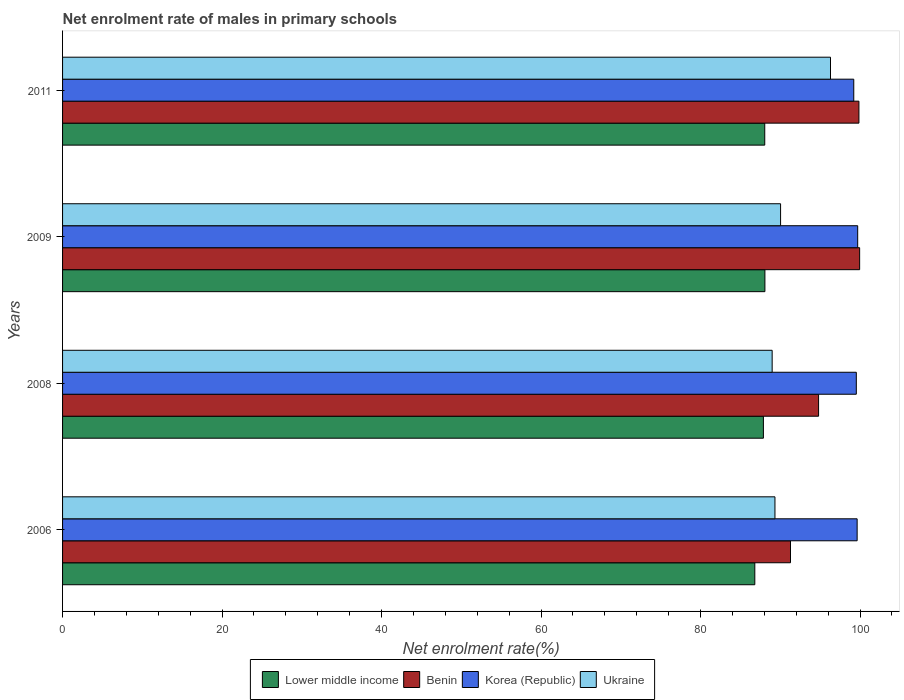How many groups of bars are there?
Offer a terse response. 4. Are the number of bars per tick equal to the number of legend labels?
Offer a very short reply. Yes. Are the number of bars on each tick of the Y-axis equal?
Your answer should be very brief. Yes. What is the label of the 2nd group of bars from the top?
Your answer should be compact. 2009. What is the net enrolment rate of males in primary schools in Benin in 2006?
Give a very brief answer. 91.28. Across all years, what is the maximum net enrolment rate of males in primary schools in Lower middle income?
Ensure brevity in your answer.  88.07. Across all years, what is the minimum net enrolment rate of males in primary schools in Lower middle income?
Provide a succinct answer. 86.81. In which year was the net enrolment rate of males in primary schools in Benin maximum?
Provide a succinct answer. 2009. What is the total net enrolment rate of males in primary schools in Korea (Republic) in the graph?
Keep it short and to the point. 398.1. What is the difference between the net enrolment rate of males in primary schools in Benin in 2006 and that in 2008?
Your answer should be compact. -3.52. What is the difference between the net enrolment rate of males in primary schools in Korea (Republic) in 2006 and the net enrolment rate of males in primary schools in Ukraine in 2009?
Ensure brevity in your answer.  9.6. What is the average net enrolment rate of males in primary schools in Ukraine per year?
Your response must be concise. 91.16. In the year 2009, what is the difference between the net enrolment rate of males in primary schools in Korea (Republic) and net enrolment rate of males in primary schools in Benin?
Keep it short and to the point. -0.24. In how many years, is the net enrolment rate of males in primary schools in Korea (Republic) greater than 100 %?
Your response must be concise. 0. What is the ratio of the net enrolment rate of males in primary schools in Lower middle income in 2009 to that in 2011?
Your answer should be very brief. 1. Is the net enrolment rate of males in primary schools in Ukraine in 2009 less than that in 2011?
Provide a succinct answer. Yes. Is the difference between the net enrolment rate of males in primary schools in Korea (Republic) in 2006 and 2008 greater than the difference between the net enrolment rate of males in primary schools in Benin in 2006 and 2008?
Your answer should be very brief. Yes. What is the difference between the highest and the second highest net enrolment rate of males in primary schools in Ukraine?
Your answer should be compact. 6.26. What is the difference between the highest and the lowest net enrolment rate of males in primary schools in Korea (Republic)?
Give a very brief answer. 0.49. Is the sum of the net enrolment rate of males in primary schools in Lower middle income in 2008 and 2011 greater than the maximum net enrolment rate of males in primary schools in Benin across all years?
Keep it short and to the point. Yes. Is it the case that in every year, the sum of the net enrolment rate of males in primary schools in Lower middle income and net enrolment rate of males in primary schools in Ukraine is greater than the sum of net enrolment rate of males in primary schools in Benin and net enrolment rate of males in primary schools in Korea (Republic)?
Offer a very short reply. No. What does the 2nd bar from the top in 2008 represents?
Your answer should be very brief. Korea (Republic). What does the 2nd bar from the bottom in 2011 represents?
Make the answer very short. Benin. How many years are there in the graph?
Your answer should be very brief. 4. What is the difference between two consecutive major ticks on the X-axis?
Your answer should be very brief. 20. Are the values on the major ticks of X-axis written in scientific E-notation?
Your response must be concise. No. How are the legend labels stacked?
Provide a short and direct response. Horizontal. What is the title of the graph?
Your answer should be compact. Net enrolment rate of males in primary schools. What is the label or title of the X-axis?
Make the answer very short. Net enrolment rate(%). What is the label or title of the Y-axis?
Offer a very short reply. Years. What is the Net enrolment rate(%) of Lower middle income in 2006?
Provide a succinct answer. 86.81. What is the Net enrolment rate(%) of Benin in 2006?
Ensure brevity in your answer.  91.28. What is the Net enrolment rate(%) of Korea (Republic) in 2006?
Your answer should be very brief. 99.64. What is the Net enrolment rate(%) of Ukraine in 2006?
Provide a succinct answer. 89.33. What is the Net enrolment rate(%) of Lower middle income in 2008?
Your answer should be very brief. 87.88. What is the Net enrolment rate(%) of Benin in 2008?
Give a very brief answer. 94.8. What is the Net enrolment rate(%) in Korea (Republic) in 2008?
Your answer should be very brief. 99.54. What is the Net enrolment rate(%) in Ukraine in 2008?
Provide a short and direct response. 88.98. What is the Net enrolment rate(%) in Lower middle income in 2009?
Make the answer very short. 88.07. What is the Net enrolment rate(%) in Benin in 2009?
Your response must be concise. 99.95. What is the Net enrolment rate(%) in Korea (Republic) in 2009?
Give a very brief answer. 99.71. What is the Net enrolment rate(%) in Ukraine in 2009?
Your response must be concise. 90.04. What is the Net enrolment rate(%) in Lower middle income in 2011?
Make the answer very short. 88.05. What is the Net enrolment rate(%) in Benin in 2011?
Offer a terse response. 99.86. What is the Net enrolment rate(%) of Korea (Republic) in 2011?
Keep it short and to the point. 99.22. What is the Net enrolment rate(%) of Ukraine in 2011?
Offer a very short reply. 96.3. Across all years, what is the maximum Net enrolment rate(%) of Lower middle income?
Keep it short and to the point. 88.07. Across all years, what is the maximum Net enrolment rate(%) in Benin?
Ensure brevity in your answer.  99.95. Across all years, what is the maximum Net enrolment rate(%) of Korea (Republic)?
Give a very brief answer. 99.71. Across all years, what is the maximum Net enrolment rate(%) of Ukraine?
Your answer should be compact. 96.3. Across all years, what is the minimum Net enrolment rate(%) of Lower middle income?
Keep it short and to the point. 86.81. Across all years, what is the minimum Net enrolment rate(%) in Benin?
Your answer should be compact. 91.28. Across all years, what is the minimum Net enrolment rate(%) in Korea (Republic)?
Your answer should be very brief. 99.22. Across all years, what is the minimum Net enrolment rate(%) of Ukraine?
Make the answer very short. 88.98. What is the total Net enrolment rate(%) in Lower middle income in the graph?
Your answer should be compact. 350.82. What is the total Net enrolment rate(%) of Benin in the graph?
Your answer should be very brief. 385.9. What is the total Net enrolment rate(%) of Korea (Republic) in the graph?
Offer a terse response. 398.1. What is the total Net enrolment rate(%) of Ukraine in the graph?
Your answer should be very brief. 364.65. What is the difference between the Net enrolment rate(%) in Lower middle income in 2006 and that in 2008?
Offer a very short reply. -1.08. What is the difference between the Net enrolment rate(%) in Benin in 2006 and that in 2008?
Your answer should be very brief. -3.52. What is the difference between the Net enrolment rate(%) in Korea (Republic) in 2006 and that in 2008?
Provide a short and direct response. 0.1. What is the difference between the Net enrolment rate(%) in Ukraine in 2006 and that in 2008?
Offer a very short reply. 0.35. What is the difference between the Net enrolment rate(%) in Lower middle income in 2006 and that in 2009?
Keep it short and to the point. -1.27. What is the difference between the Net enrolment rate(%) of Benin in 2006 and that in 2009?
Give a very brief answer. -8.67. What is the difference between the Net enrolment rate(%) of Korea (Republic) in 2006 and that in 2009?
Give a very brief answer. -0.07. What is the difference between the Net enrolment rate(%) in Ukraine in 2006 and that in 2009?
Your response must be concise. -0.71. What is the difference between the Net enrolment rate(%) of Lower middle income in 2006 and that in 2011?
Ensure brevity in your answer.  -1.25. What is the difference between the Net enrolment rate(%) in Benin in 2006 and that in 2011?
Offer a very short reply. -8.58. What is the difference between the Net enrolment rate(%) of Korea (Republic) in 2006 and that in 2011?
Give a very brief answer. 0.42. What is the difference between the Net enrolment rate(%) of Ukraine in 2006 and that in 2011?
Your response must be concise. -6.97. What is the difference between the Net enrolment rate(%) of Lower middle income in 2008 and that in 2009?
Make the answer very short. -0.19. What is the difference between the Net enrolment rate(%) in Benin in 2008 and that in 2009?
Provide a succinct answer. -5.15. What is the difference between the Net enrolment rate(%) of Korea (Republic) in 2008 and that in 2009?
Keep it short and to the point. -0.17. What is the difference between the Net enrolment rate(%) in Ukraine in 2008 and that in 2009?
Provide a short and direct response. -1.06. What is the difference between the Net enrolment rate(%) in Lower middle income in 2008 and that in 2011?
Your answer should be very brief. -0.17. What is the difference between the Net enrolment rate(%) in Benin in 2008 and that in 2011?
Your response must be concise. -5.06. What is the difference between the Net enrolment rate(%) of Korea (Republic) in 2008 and that in 2011?
Ensure brevity in your answer.  0.32. What is the difference between the Net enrolment rate(%) in Ukraine in 2008 and that in 2011?
Keep it short and to the point. -7.32. What is the difference between the Net enrolment rate(%) of Lower middle income in 2009 and that in 2011?
Offer a very short reply. 0.02. What is the difference between the Net enrolment rate(%) of Benin in 2009 and that in 2011?
Ensure brevity in your answer.  0.09. What is the difference between the Net enrolment rate(%) of Korea (Republic) in 2009 and that in 2011?
Your response must be concise. 0.49. What is the difference between the Net enrolment rate(%) in Ukraine in 2009 and that in 2011?
Make the answer very short. -6.26. What is the difference between the Net enrolment rate(%) in Lower middle income in 2006 and the Net enrolment rate(%) in Benin in 2008?
Make the answer very short. -8. What is the difference between the Net enrolment rate(%) in Lower middle income in 2006 and the Net enrolment rate(%) in Korea (Republic) in 2008?
Offer a terse response. -12.73. What is the difference between the Net enrolment rate(%) in Lower middle income in 2006 and the Net enrolment rate(%) in Ukraine in 2008?
Provide a succinct answer. -2.18. What is the difference between the Net enrolment rate(%) of Benin in 2006 and the Net enrolment rate(%) of Korea (Republic) in 2008?
Offer a very short reply. -8.25. What is the difference between the Net enrolment rate(%) of Benin in 2006 and the Net enrolment rate(%) of Ukraine in 2008?
Offer a terse response. 2.3. What is the difference between the Net enrolment rate(%) of Korea (Republic) in 2006 and the Net enrolment rate(%) of Ukraine in 2008?
Your answer should be compact. 10.66. What is the difference between the Net enrolment rate(%) in Lower middle income in 2006 and the Net enrolment rate(%) in Benin in 2009?
Provide a succinct answer. -13.15. What is the difference between the Net enrolment rate(%) in Lower middle income in 2006 and the Net enrolment rate(%) in Korea (Republic) in 2009?
Ensure brevity in your answer.  -12.9. What is the difference between the Net enrolment rate(%) of Lower middle income in 2006 and the Net enrolment rate(%) of Ukraine in 2009?
Your answer should be very brief. -3.23. What is the difference between the Net enrolment rate(%) in Benin in 2006 and the Net enrolment rate(%) in Korea (Republic) in 2009?
Your answer should be compact. -8.43. What is the difference between the Net enrolment rate(%) in Benin in 2006 and the Net enrolment rate(%) in Ukraine in 2009?
Offer a terse response. 1.24. What is the difference between the Net enrolment rate(%) of Korea (Republic) in 2006 and the Net enrolment rate(%) of Ukraine in 2009?
Your answer should be compact. 9.6. What is the difference between the Net enrolment rate(%) in Lower middle income in 2006 and the Net enrolment rate(%) in Benin in 2011?
Ensure brevity in your answer.  -13.06. What is the difference between the Net enrolment rate(%) in Lower middle income in 2006 and the Net enrolment rate(%) in Korea (Republic) in 2011?
Offer a terse response. -12.41. What is the difference between the Net enrolment rate(%) of Lower middle income in 2006 and the Net enrolment rate(%) of Ukraine in 2011?
Your answer should be compact. -9.49. What is the difference between the Net enrolment rate(%) in Benin in 2006 and the Net enrolment rate(%) in Korea (Republic) in 2011?
Ensure brevity in your answer.  -7.94. What is the difference between the Net enrolment rate(%) of Benin in 2006 and the Net enrolment rate(%) of Ukraine in 2011?
Ensure brevity in your answer.  -5.02. What is the difference between the Net enrolment rate(%) in Korea (Republic) in 2006 and the Net enrolment rate(%) in Ukraine in 2011?
Offer a terse response. 3.34. What is the difference between the Net enrolment rate(%) of Lower middle income in 2008 and the Net enrolment rate(%) of Benin in 2009?
Your answer should be compact. -12.07. What is the difference between the Net enrolment rate(%) of Lower middle income in 2008 and the Net enrolment rate(%) of Korea (Republic) in 2009?
Offer a terse response. -11.82. What is the difference between the Net enrolment rate(%) of Lower middle income in 2008 and the Net enrolment rate(%) of Ukraine in 2009?
Offer a very short reply. -2.15. What is the difference between the Net enrolment rate(%) in Benin in 2008 and the Net enrolment rate(%) in Korea (Republic) in 2009?
Provide a short and direct response. -4.9. What is the difference between the Net enrolment rate(%) in Benin in 2008 and the Net enrolment rate(%) in Ukraine in 2009?
Offer a very short reply. 4.77. What is the difference between the Net enrolment rate(%) in Korea (Republic) in 2008 and the Net enrolment rate(%) in Ukraine in 2009?
Make the answer very short. 9.5. What is the difference between the Net enrolment rate(%) in Lower middle income in 2008 and the Net enrolment rate(%) in Benin in 2011?
Make the answer very short. -11.98. What is the difference between the Net enrolment rate(%) in Lower middle income in 2008 and the Net enrolment rate(%) in Korea (Republic) in 2011?
Make the answer very short. -11.33. What is the difference between the Net enrolment rate(%) of Lower middle income in 2008 and the Net enrolment rate(%) of Ukraine in 2011?
Make the answer very short. -8.41. What is the difference between the Net enrolment rate(%) in Benin in 2008 and the Net enrolment rate(%) in Korea (Republic) in 2011?
Give a very brief answer. -4.41. What is the difference between the Net enrolment rate(%) of Benin in 2008 and the Net enrolment rate(%) of Ukraine in 2011?
Keep it short and to the point. -1.49. What is the difference between the Net enrolment rate(%) in Korea (Republic) in 2008 and the Net enrolment rate(%) in Ukraine in 2011?
Ensure brevity in your answer.  3.24. What is the difference between the Net enrolment rate(%) in Lower middle income in 2009 and the Net enrolment rate(%) in Benin in 2011?
Ensure brevity in your answer.  -11.79. What is the difference between the Net enrolment rate(%) in Lower middle income in 2009 and the Net enrolment rate(%) in Korea (Republic) in 2011?
Your response must be concise. -11.14. What is the difference between the Net enrolment rate(%) of Lower middle income in 2009 and the Net enrolment rate(%) of Ukraine in 2011?
Provide a short and direct response. -8.23. What is the difference between the Net enrolment rate(%) in Benin in 2009 and the Net enrolment rate(%) in Korea (Republic) in 2011?
Provide a short and direct response. 0.74. What is the difference between the Net enrolment rate(%) of Benin in 2009 and the Net enrolment rate(%) of Ukraine in 2011?
Provide a short and direct response. 3.65. What is the difference between the Net enrolment rate(%) of Korea (Republic) in 2009 and the Net enrolment rate(%) of Ukraine in 2011?
Offer a terse response. 3.41. What is the average Net enrolment rate(%) in Lower middle income per year?
Keep it short and to the point. 87.7. What is the average Net enrolment rate(%) of Benin per year?
Provide a succinct answer. 96.48. What is the average Net enrolment rate(%) in Korea (Republic) per year?
Your response must be concise. 99.52. What is the average Net enrolment rate(%) in Ukraine per year?
Provide a short and direct response. 91.16. In the year 2006, what is the difference between the Net enrolment rate(%) in Lower middle income and Net enrolment rate(%) in Benin?
Provide a short and direct response. -4.47. In the year 2006, what is the difference between the Net enrolment rate(%) of Lower middle income and Net enrolment rate(%) of Korea (Republic)?
Ensure brevity in your answer.  -12.83. In the year 2006, what is the difference between the Net enrolment rate(%) in Lower middle income and Net enrolment rate(%) in Ukraine?
Provide a short and direct response. -2.53. In the year 2006, what is the difference between the Net enrolment rate(%) of Benin and Net enrolment rate(%) of Korea (Republic)?
Your response must be concise. -8.36. In the year 2006, what is the difference between the Net enrolment rate(%) in Benin and Net enrolment rate(%) in Ukraine?
Provide a succinct answer. 1.95. In the year 2006, what is the difference between the Net enrolment rate(%) of Korea (Republic) and Net enrolment rate(%) of Ukraine?
Provide a succinct answer. 10.31. In the year 2008, what is the difference between the Net enrolment rate(%) of Lower middle income and Net enrolment rate(%) of Benin?
Make the answer very short. -6.92. In the year 2008, what is the difference between the Net enrolment rate(%) of Lower middle income and Net enrolment rate(%) of Korea (Republic)?
Make the answer very short. -11.65. In the year 2008, what is the difference between the Net enrolment rate(%) in Lower middle income and Net enrolment rate(%) in Ukraine?
Your response must be concise. -1.1. In the year 2008, what is the difference between the Net enrolment rate(%) of Benin and Net enrolment rate(%) of Korea (Republic)?
Make the answer very short. -4.73. In the year 2008, what is the difference between the Net enrolment rate(%) in Benin and Net enrolment rate(%) in Ukraine?
Your answer should be compact. 5.82. In the year 2008, what is the difference between the Net enrolment rate(%) in Korea (Republic) and Net enrolment rate(%) in Ukraine?
Your answer should be compact. 10.55. In the year 2009, what is the difference between the Net enrolment rate(%) of Lower middle income and Net enrolment rate(%) of Benin?
Give a very brief answer. -11.88. In the year 2009, what is the difference between the Net enrolment rate(%) of Lower middle income and Net enrolment rate(%) of Korea (Republic)?
Ensure brevity in your answer.  -11.63. In the year 2009, what is the difference between the Net enrolment rate(%) of Lower middle income and Net enrolment rate(%) of Ukraine?
Your answer should be very brief. -1.97. In the year 2009, what is the difference between the Net enrolment rate(%) of Benin and Net enrolment rate(%) of Korea (Republic)?
Provide a short and direct response. 0.24. In the year 2009, what is the difference between the Net enrolment rate(%) of Benin and Net enrolment rate(%) of Ukraine?
Give a very brief answer. 9.91. In the year 2009, what is the difference between the Net enrolment rate(%) of Korea (Republic) and Net enrolment rate(%) of Ukraine?
Your response must be concise. 9.67. In the year 2011, what is the difference between the Net enrolment rate(%) of Lower middle income and Net enrolment rate(%) of Benin?
Give a very brief answer. -11.81. In the year 2011, what is the difference between the Net enrolment rate(%) in Lower middle income and Net enrolment rate(%) in Korea (Republic)?
Offer a very short reply. -11.16. In the year 2011, what is the difference between the Net enrolment rate(%) in Lower middle income and Net enrolment rate(%) in Ukraine?
Provide a short and direct response. -8.25. In the year 2011, what is the difference between the Net enrolment rate(%) of Benin and Net enrolment rate(%) of Korea (Republic)?
Provide a succinct answer. 0.65. In the year 2011, what is the difference between the Net enrolment rate(%) of Benin and Net enrolment rate(%) of Ukraine?
Your response must be concise. 3.56. In the year 2011, what is the difference between the Net enrolment rate(%) of Korea (Republic) and Net enrolment rate(%) of Ukraine?
Provide a succinct answer. 2.92. What is the ratio of the Net enrolment rate(%) in Benin in 2006 to that in 2008?
Offer a very short reply. 0.96. What is the ratio of the Net enrolment rate(%) of Ukraine in 2006 to that in 2008?
Provide a short and direct response. 1. What is the ratio of the Net enrolment rate(%) in Lower middle income in 2006 to that in 2009?
Your answer should be very brief. 0.99. What is the ratio of the Net enrolment rate(%) in Benin in 2006 to that in 2009?
Keep it short and to the point. 0.91. What is the ratio of the Net enrolment rate(%) of Korea (Republic) in 2006 to that in 2009?
Ensure brevity in your answer.  1. What is the ratio of the Net enrolment rate(%) of Ukraine in 2006 to that in 2009?
Offer a very short reply. 0.99. What is the ratio of the Net enrolment rate(%) of Lower middle income in 2006 to that in 2011?
Ensure brevity in your answer.  0.99. What is the ratio of the Net enrolment rate(%) in Benin in 2006 to that in 2011?
Keep it short and to the point. 0.91. What is the ratio of the Net enrolment rate(%) in Ukraine in 2006 to that in 2011?
Give a very brief answer. 0.93. What is the ratio of the Net enrolment rate(%) in Lower middle income in 2008 to that in 2009?
Your answer should be very brief. 1. What is the ratio of the Net enrolment rate(%) in Benin in 2008 to that in 2009?
Keep it short and to the point. 0.95. What is the ratio of the Net enrolment rate(%) of Ukraine in 2008 to that in 2009?
Ensure brevity in your answer.  0.99. What is the ratio of the Net enrolment rate(%) of Lower middle income in 2008 to that in 2011?
Offer a very short reply. 1. What is the ratio of the Net enrolment rate(%) of Benin in 2008 to that in 2011?
Offer a terse response. 0.95. What is the ratio of the Net enrolment rate(%) in Korea (Republic) in 2008 to that in 2011?
Provide a succinct answer. 1. What is the ratio of the Net enrolment rate(%) of Ukraine in 2008 to that in 2011?
Ensure brevity in your answer.  0.92. What is the ratio of the Net enrolment rate(%) of Benin in 2009 to that in 2011?
Your answer should be very brief. 1. What is the ratio of the Net enrolment rate(%) of Ukraine in 2009 to that in 2011?
Offer a very short reply. 0.94. What is the difference between the highest and the second highest Net enrolment rate(%) in Lower middle income?
Ensure brevity in your answer.  0.02. What is the difference between the highest and the second highest Net enrolment rate(%) of Benin?
Give a very brief answer. 0.09. What is the difference between the highest and the second highest Net enrolment rate(%) in Korea (Republic)?
Make the answer very short. 0.07. What is the difference between the highest and the second highest Net enrolment rate(%) in Ukraine?
Offer a very short reply. 6.26. What is the difference between the highest and the lowest Net enrolment rate(%) in Lower middle income?
Provide a succinct answer. 1.27. What is the difference between the highest and the lowest Net enrolment rate(%) of Benin?
Give a very brief answer. 8.67. What is the difference between the highest and the lowest Net enrolment rate(%) of Korea (Republic)?
Your answer should be very brief. 0.49. What is the difference between the highest and the lowest Net enrolment rate(%) in Ukraine?
Your answer should be compact. 7.32. 